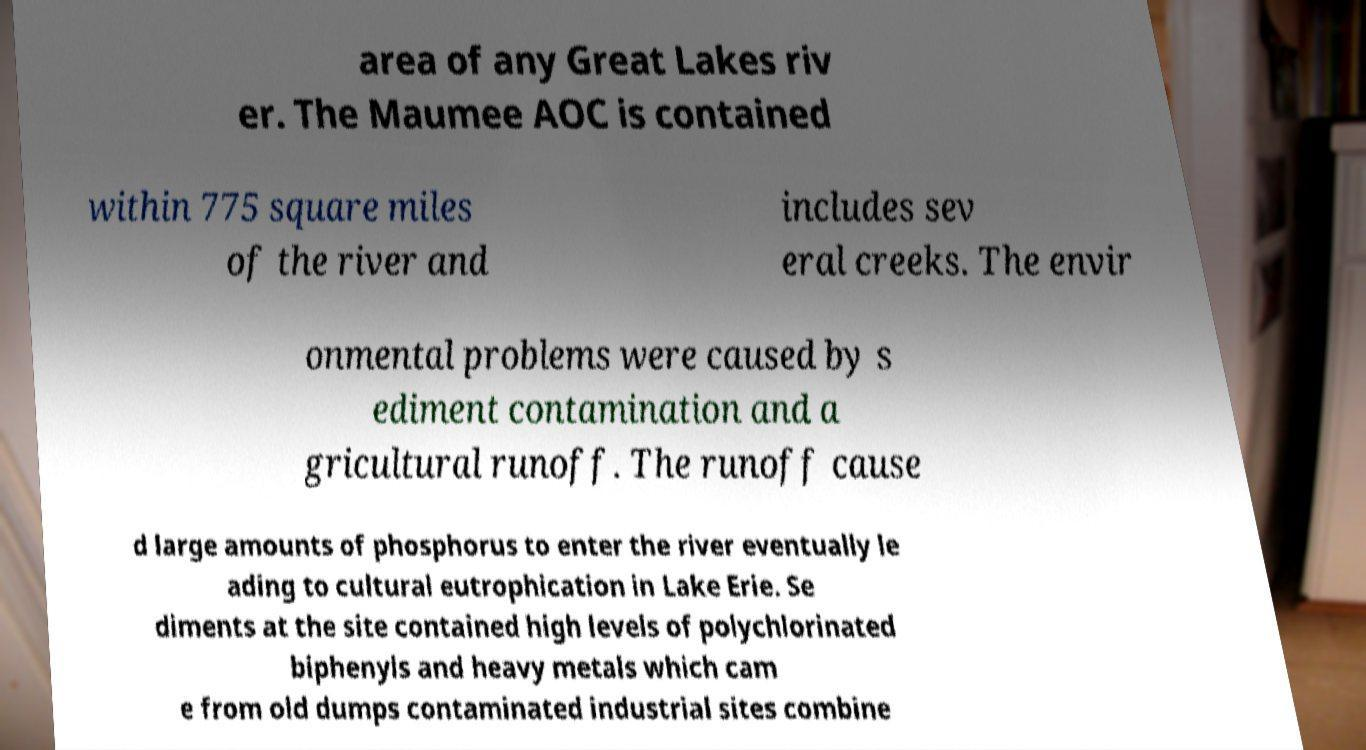Please identify and transcribe the text found in this image. area of any Great Lakes riv er. The Maumee AOC is contained within 775 square miles of the river and includes sev eral creeks. The envir onmental problems were caused by s ediment contamination and a gricultural runoff. The runoff cause d large amounts of phosphorus to enter the river eventually le ading to cultural eutrophication in Lake Erie. Se diments at the site contained high levels of polychlorinated biphenyls and heavy metals which cam e from old dumps contaminated industrial sites combine 